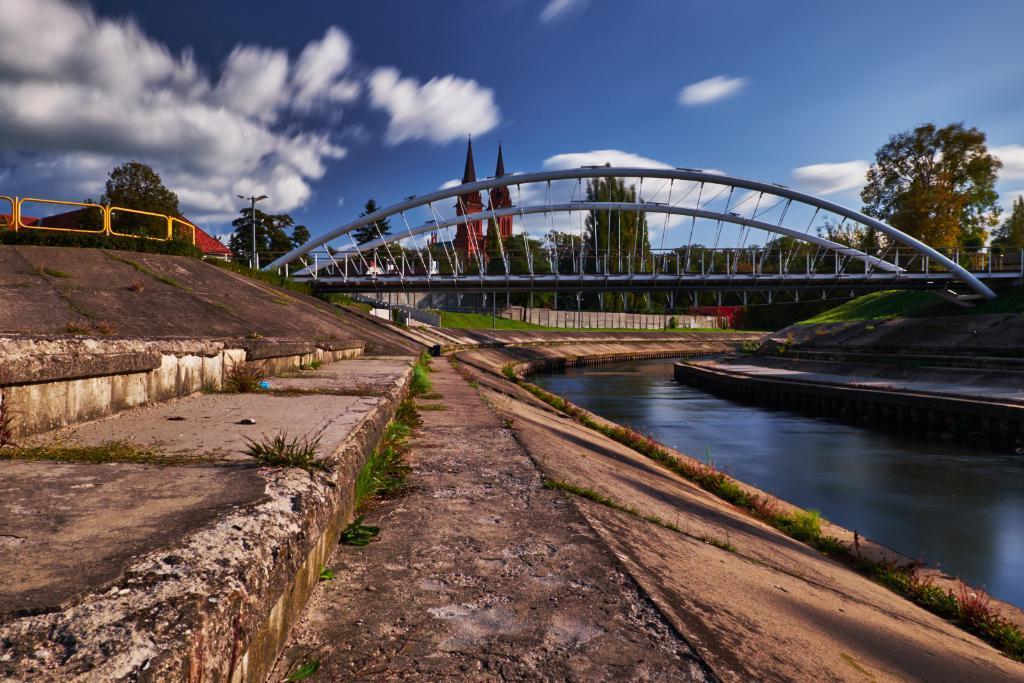How would you summarize this image in a sentence or two? This looks like a canal and we can see water here. We can also see a foot over bridge,poles,fences. In the background there are trees,buildings,light poles and clouds in the sky. 